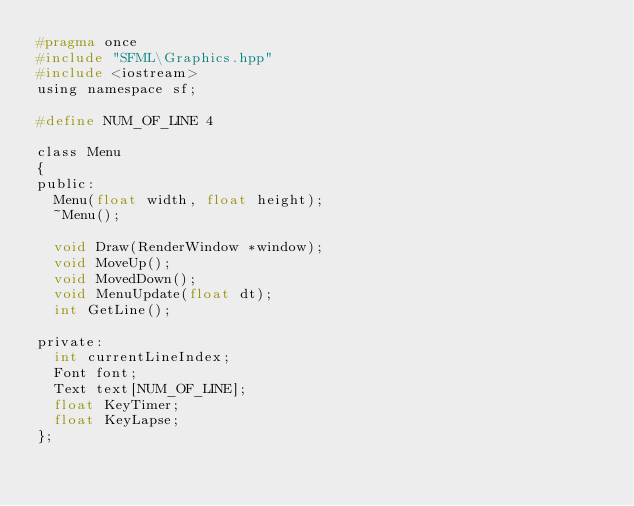<code> <loc_0><loc_0><loc_500><loc_500><_C_>#pragma once
#include "SFML\Graphics.hpp"
#include <iostream>
using namespace sf;

#define NUM_OF_LINE 4

class Menu
{
public:
	Menu(float width, float height);
	~Menu();

	void Draw(RenderWindow *window);
	void MoveUp();
	void MovedDown();
	void MenuUpdate(float dt);
	int GetLine();

private:
	int currentLineIndex;
	Font font;
	Text text[NUM_OF_LINE];
	float KeyTimer;
	float KeyLapse;
};

</code> 